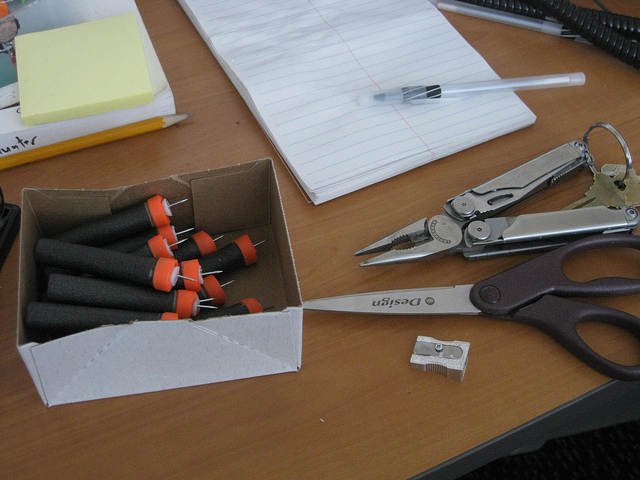Identify and read out the text in this image. Design unter 